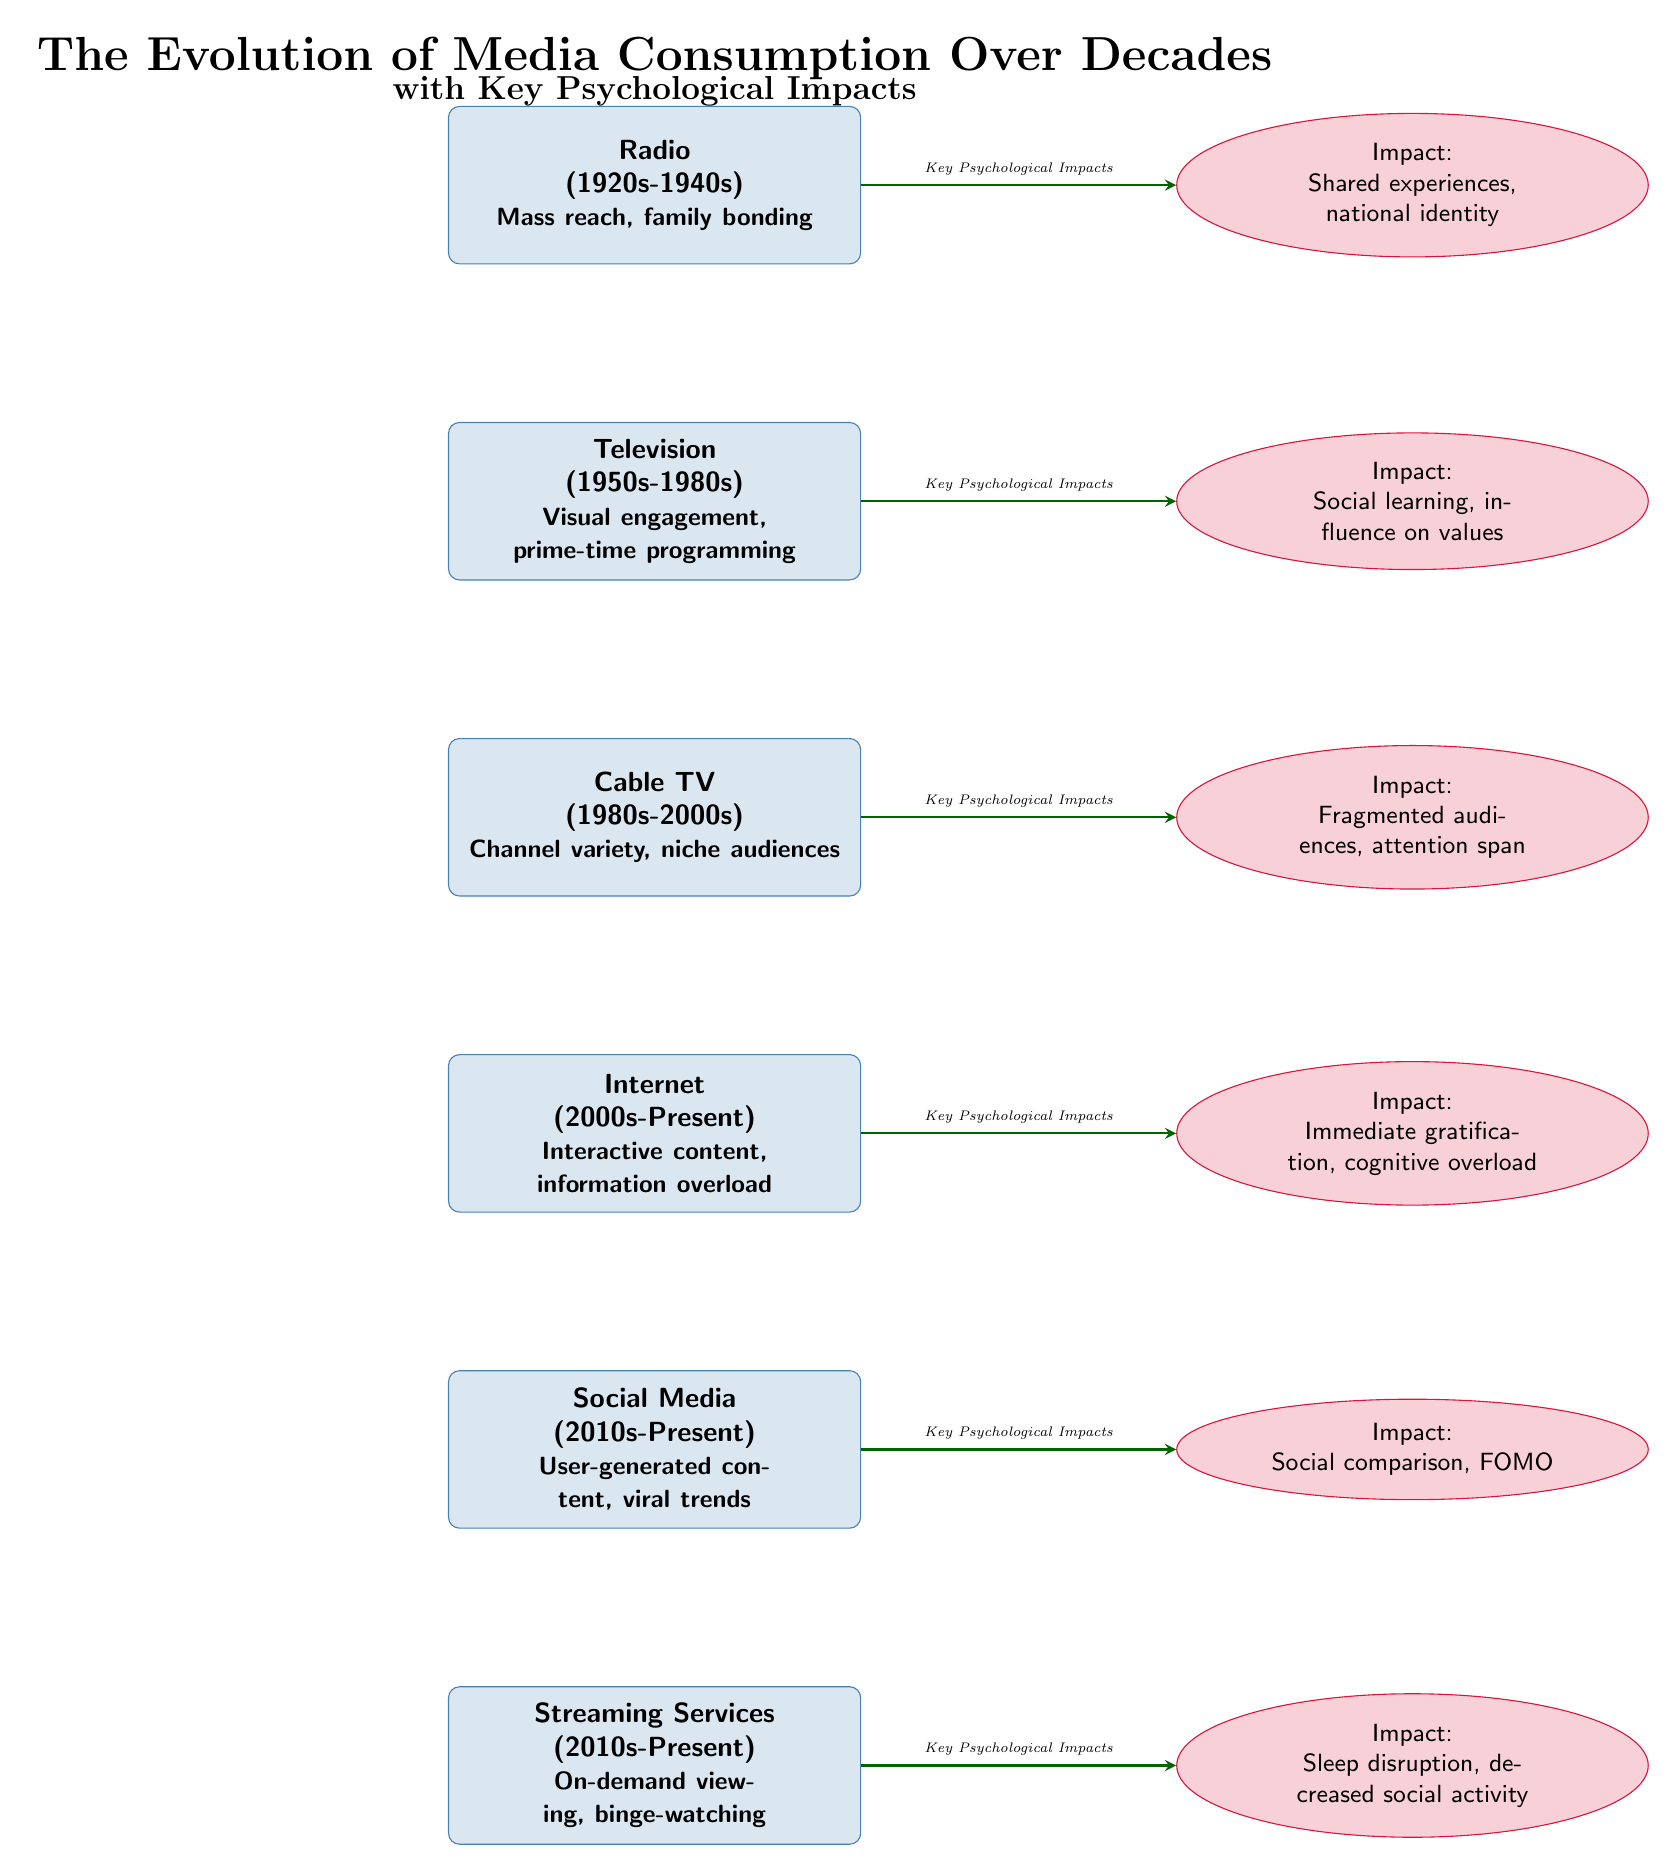What media type corresponds to the decade 1950s-1980s? The media type for the 1950s-1980s in the diagram is labeled as "Television". This can be directly identified from the node description under that specific time frame.
Answer: Television What impact is associated with Cable TV? The impact listed for Cable TV in the diagram is "Fragmented audiences, attention span". This is taken directly from the corresponding impact node for Cable TV.
Answer: Fragmented audiences, attention span How many media types are represented in the diagram? By counting the distinct media nodes present, there are a total of six media types outlined in the diagram. Each media type represents a different era of media consumption.
Answer: 6 Which media type is linked to the impact of "Cognitive overload"? The media type linked to "Cognitive overload" is "Internet". The connection can be traced by following the arrow from the Internet node to its corresponding impact node.
Answer: Internet What is the key psychological impact of Social Media as depicted in the diagram? The key psychological impact associated with Social Media is "Social comparison, FOMO". This description is presented in the impact node next to the Social Media media type.
Answer: Social comparison, FOMO What relationship do Streaming Services and Sleep disruption have? Streaming Services are linked to the impact of sleep disruption through the arrow connecting these two nodes. This demonstrates how this media type influences that specific psychological impact.
Answer: Sleep disruption Explain the progression of media types from the earliest to the latest. The media types progress from Radio in the 1920s-1940s, to Television in the 1950s-1980s, followed by Cable TV in the 1980s-2000s, then Internet in the 2000s-Present, Social Media in the 2010s-Present, and finally Streaming Services also in the 2010s-Present. This is visually organized in a vertical list in the diagram.
Answer: Radio, Television, Cable TV, Internet, Social Media, Streaming Services What does the arrow represent in the diagram between media types and impacts? The arrow indicates the relationship between each media type and its corresponding psychological impact, showing how different media forms influence viewer behavior and psychological outcomes.
Answer: Key Psychological Impacts 